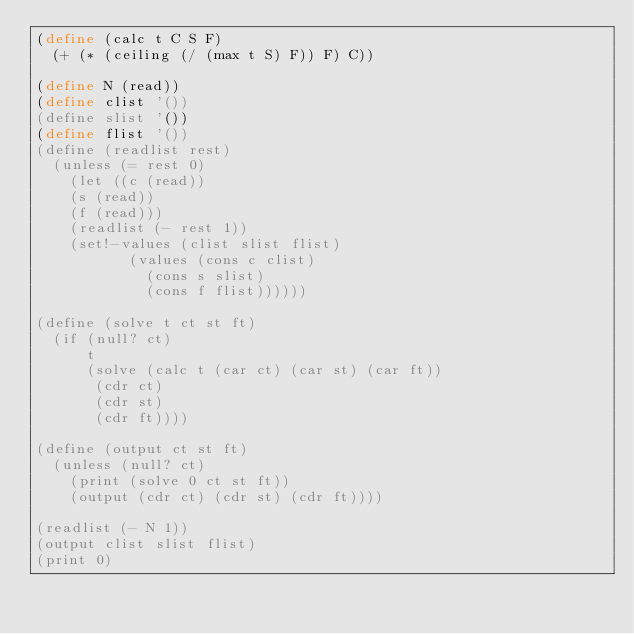Convert code to text. <code><loc_0><loc_0><loc_500><loc_500><_Scheme_>(define (calc t C S F)
  (+ (* (ceiling (/ (max t S) F)) F) C))

(define N (read))
(define clist '())
(define slist '())
(define flist '())
(define (readlist rest)
  (unless (= rest 0)
	  (let ((c (read))
		(s (read))
		(f (read)))
	  (readlist (- rest 1))
	  (set!-values (clist slist flist)
		       (values (cons c clist)
			       (cons s slist)
			       (cons f flist))))))

(define (solve t ct st ft)
  (if (null? ct)
      t
      (solve (calc t (car ct) (car st) (car ft))
	     (cdr ct)
	     (cdr st)
	     (cdr ft))))

(define (output ct st ft)
  (unless (null? ct)
	  (print (solve 0 ct st ft))
	  (output (cdr ct) (cdr st) (cdr ft))))

(readlist (- N 1))
(output clist slist flist)
(print 0)
</code> 